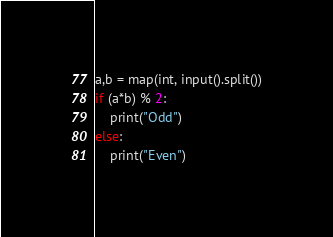Convert code to text. <code><loc_0><loc_0><loc_500><loc_500><_Python_>a,b = map(int, input().split())
if (a*b) % 2:
    print("Odd")
else:
    print("Even")</code> 